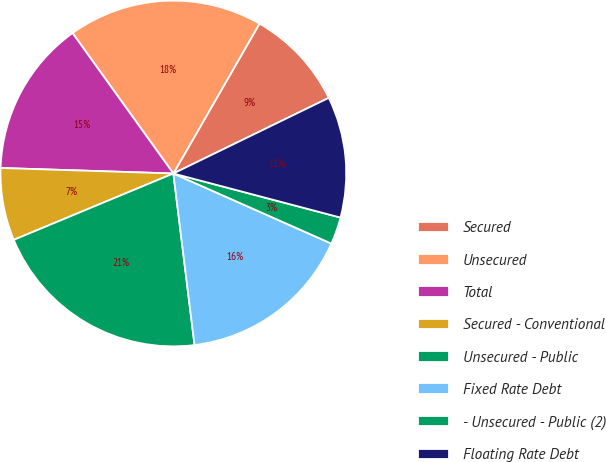Convert chart. <chart><loc_0><loc_0><loc_500><loc_500><pie_chart><fcel>Secured<fcel>Unsecured<fcel>Total<fcel>Secured - Conventional<fcel>Unsecured - Public<fcel>Fixed Rate Debt<fcel>- Unsecured - Public (2)<fcel>Floating Rate Debt<nl><fcel>9.49%<fcel>18.21%<fcel>14.58%<fcel>6.78%<fcel>20.68%<fcel>16.4%<fcel>2.54%<fcel>11.31%<nl></chart> 